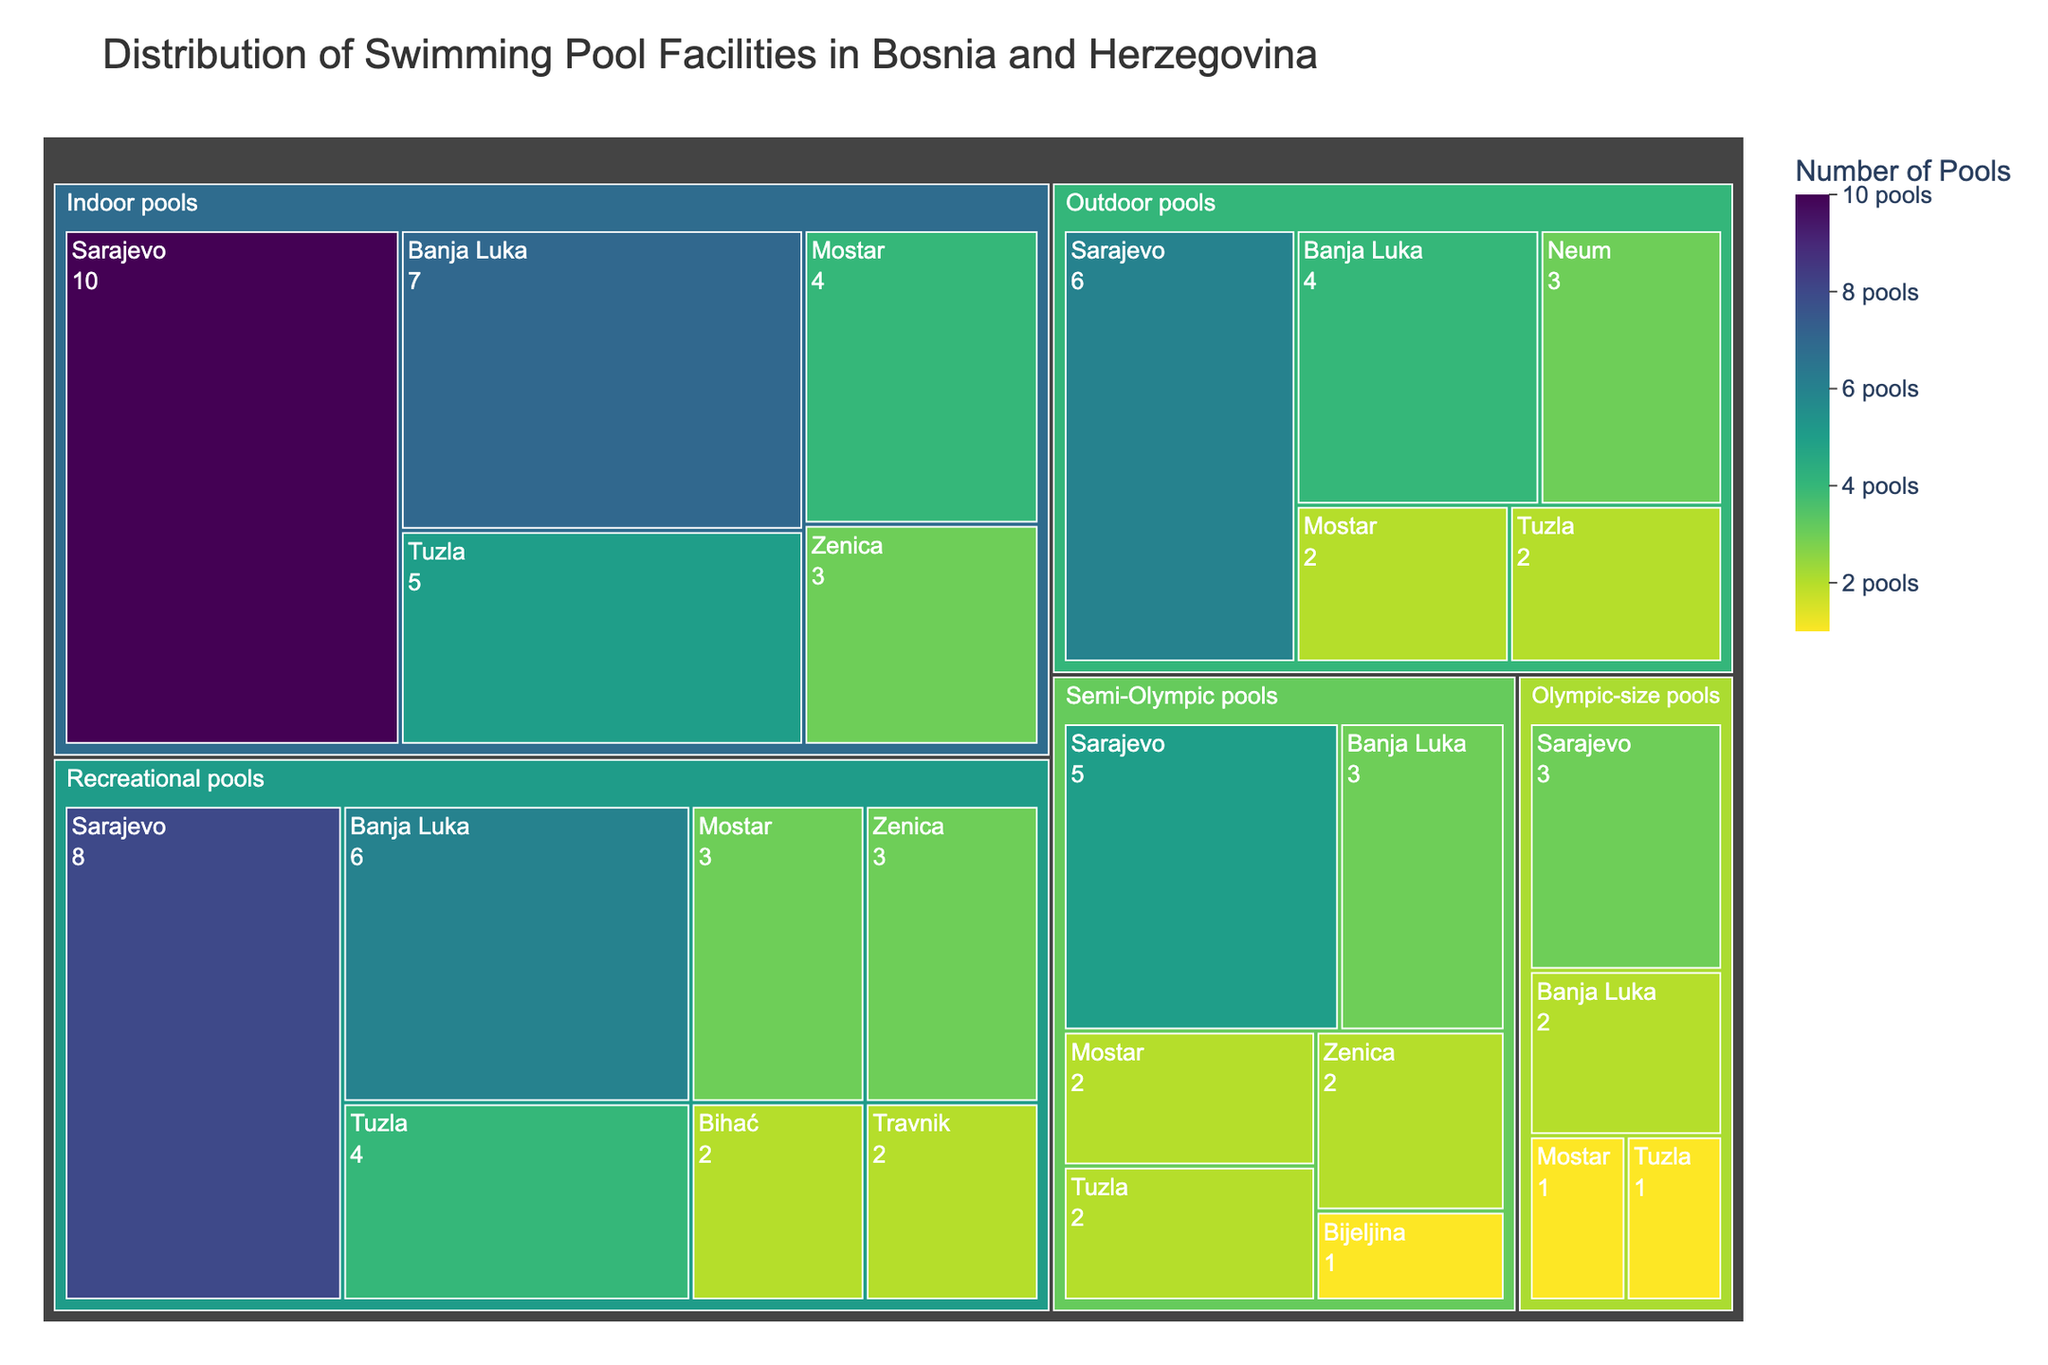What's the title of the treemap? The title is usually located at the top of the visualization and describes what the visualization is about.
Answer: Distribution of Swimming Pool Facilities in Bosnia and Herzegovina Which category has the largest number of pools in Sarajevo? By looking at the different categories within Sarajevo, find the one with the largest number value.
Answer: Indoor pools How many Olympic-size pools are there across all cities? To find this, add the values of Olympic-size pools from each city: 3 (Sarajevo) + 2 (Banja Luka) + 1 (Tuzla) + 1 (Mostar).
Answer: 7 Which city has more recreational pools, Banja Luka or Tuzla? Look at the subcategories under Recreational pools and compare the values for Banja Luka and Tuzla.
Answer: Banja Luka What is the total number of pools in Mostar? Sum up the number of pools in each category in Mostar: 1 (Olympic-size) + 2 (Semi-Olympic) + 3 (Recreational) + 4 (Indoor) + 2 (Outdoor).
Answer: 12 Compare the number of outdoor pools in Neum with those in Tuzla. Which has more? Look at the subcategory Outdoor pools and compare the values for Neum and Tuzla.
Answer: Neum Which category has the smallest distribution across all cities? Look at the overall treemap and find which category has the smallest combined value.
Answer: Olympic-size pools How many more indoor pools does Sarajevo have compared to Mostar? Subtract the number of indoor pools in Mostar from those in Sarajevo: 10 (Sarajevo) - 4 (Mostar).
Answer: 6 Which category of pools has the highest value in Banja Luka? Look at the different categories within Banja Luka and identify the one with the highest number value.
Answer: Indoor pools What is the combined number of Semi-Olympic pools in all cities? Sum up the number of Semi-Olympic pools from all cities: 5 (Sarajevo) + 3 (Banja Luka) + 2 (Tuzla) + 2 (Zenica) + 2 (Mostar) + 1 (Bijeljina).
Answer: 15 